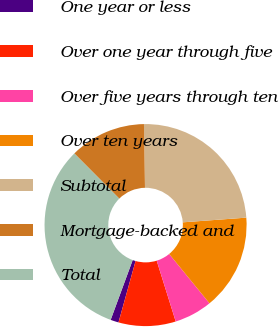Convert chart. <chart><loc_0><loc_0><loc_500><loc_500><pie_chart><fcel>One year or less<fcel>Over one year through five<fcel>Over five years through ten<fcel>Over ten years<fcel>Subtotal<fcel>Mortgage-backed and<fcel>Total<nl><fcel>1.3%<fcel>9.14%<fcel>6.08%<fcel>15.27%<fcel>24.08%<fcel>12.21%<fcel>31.92%<nl></chart> 